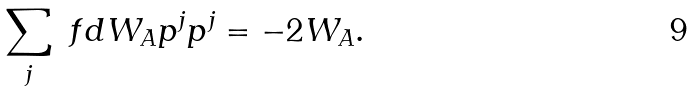<formula> <loc_0><loc_0><loc_500><loc_500>\sum _ { j } \ f d { W _ { A } } { p ^ { j } } p ^ { j } = - 2 W _ { A } .</formula> 